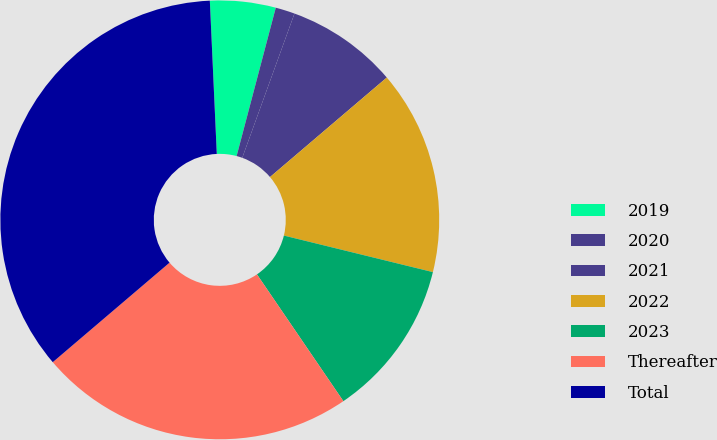<chart> <loc_0><loc_0><loc_500><loc_500><pie_chart><fcel>2019<fcel>2020<fcel>2021<fcel>2022<fcel>2023<fcel>Thereafter<fcel>Total<nl><fcel>4.83%<fcel>1.42%<fcel>8.24%<fcel>15.06%<fcel>11.65%<fcel>23.29%<fcel>35.51%<nl></chart> 